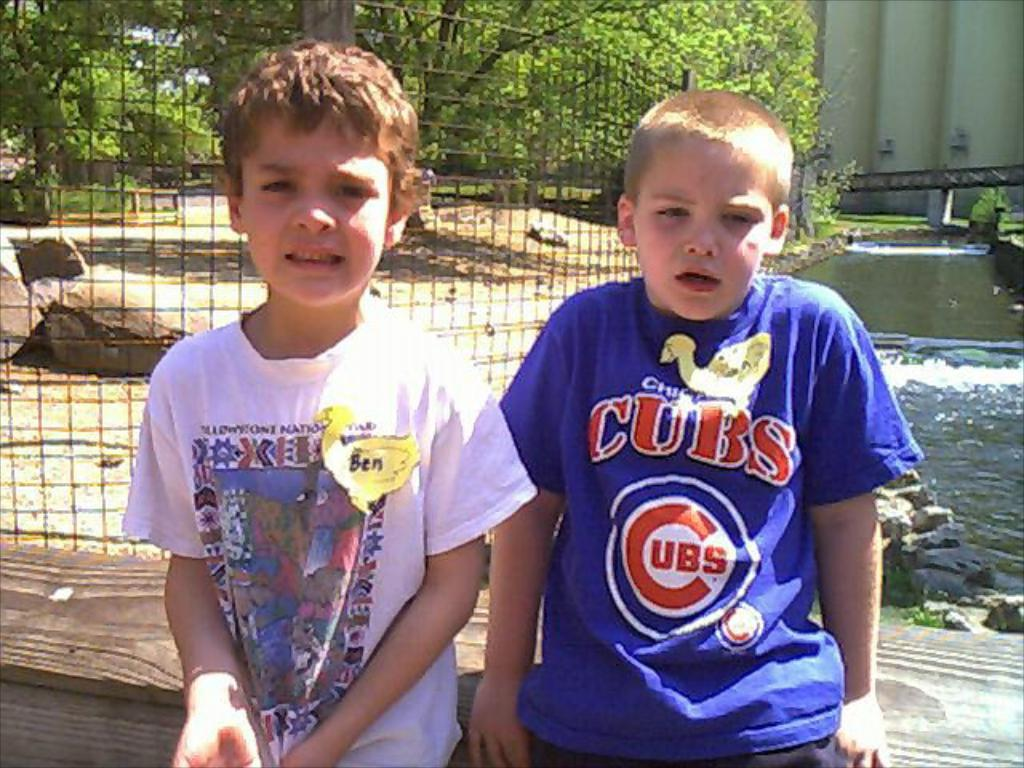<image>
Relay a brief, clear account of the picture shown. a kid that is wearing a Cubs shirt 